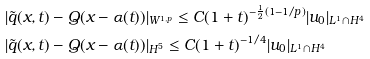Convert formula to latex. <formula><loc_0><loc_0><loc_500><loc_500>& | \tilde { q } ( x , t ) - Q ( x - \alpha ( t ) ) | _ { W ^ { 1 , p } } \leq C ( 1 + t ) ^ { - \frac { 1 } { 2 } ( 1 - 1 / p ) } | u _ { 0 } | _ { L ^ { 1 } \cap H ^ { 4 } } \\ & | \tilde { q } ( x , t ) - Q ( x - \alpha ( t ) ) | _ { H ^ { 5 } } \leq C ( 1 + t ) ^ { - 1 / 4 } | u _ { 0 } | _ { L ^ { 1 } \cap H ^ { 4 } }</formula> 